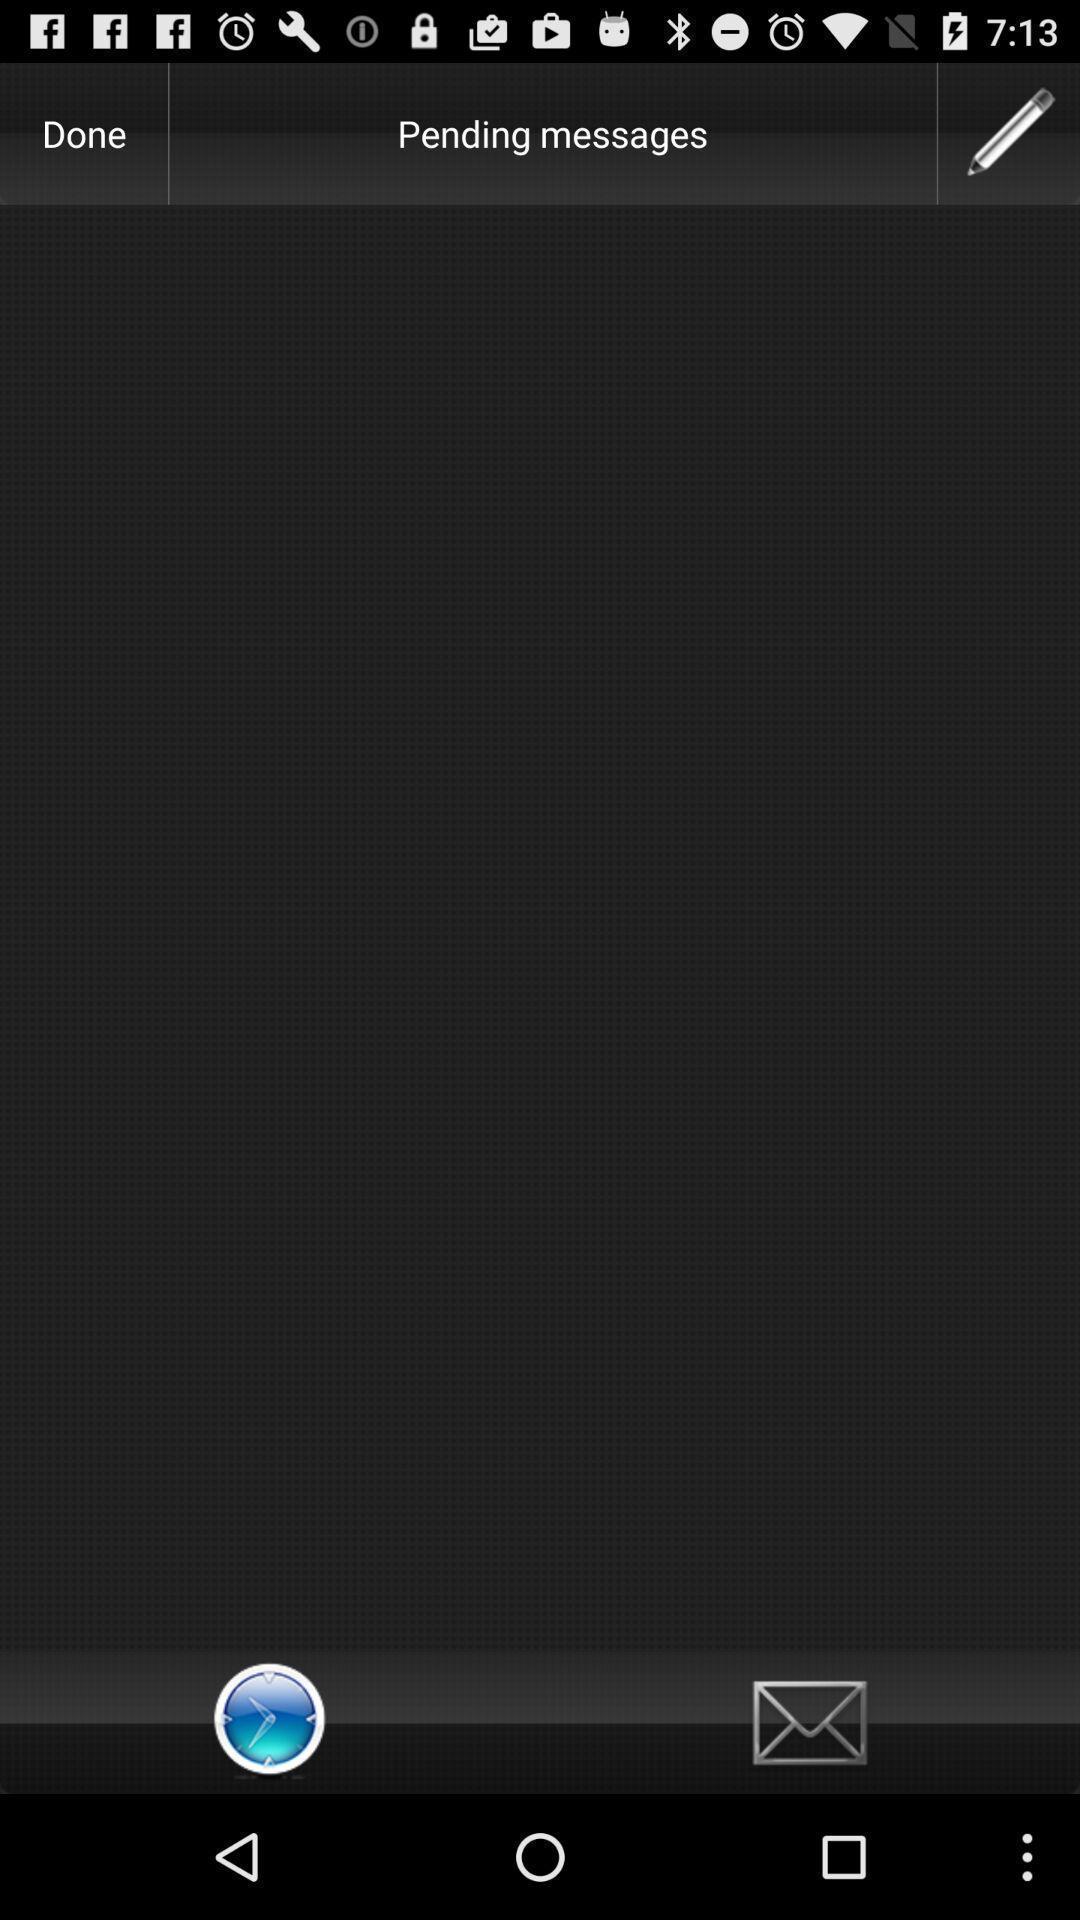Describe the key features of this screenshot. Screen displaying the blank page in pending messages. 